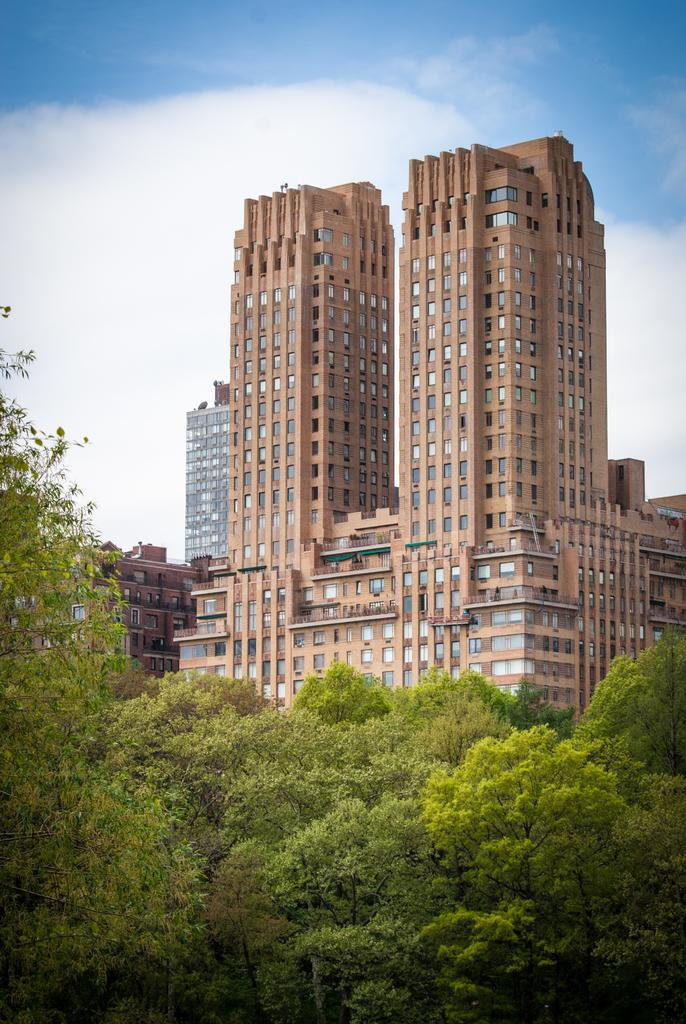What type of structures can be seen in the image? There are buildings in the image. What other natural elements are present in the image? There are trees in the image. What is visible in the background of the image? The sky is visible in the background of the image. How would you describe the weather based on the sky in the image? The sky appears to be clear, suggesting good weather. What type of pies are being baked in the buildings in the image? There is no indication of pies or baking in the image; it only shows buildings, trees, and the sky. 